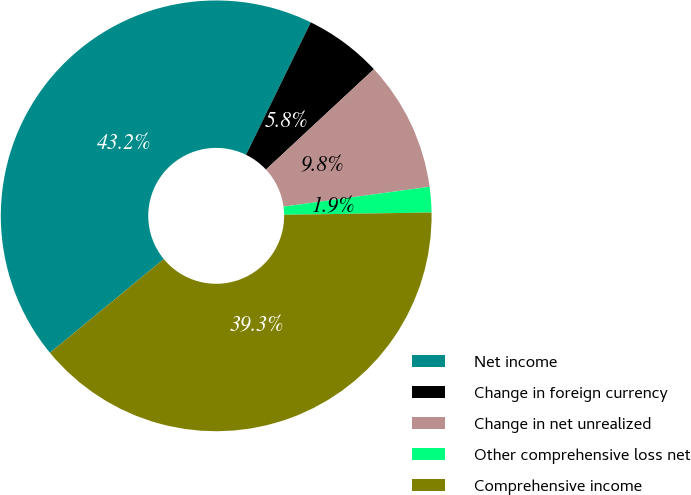<chart> <loc_0><loc_0><loc_500><loc_500><pie_chart><fcel>Net income<fcel>Change in foreign currency<fcel>Change in net unrealized<fcel>Other comprehensive loss net<fcel>Comprehensive income<nl><fcel>43.21%<fcel>5.84%<fcel>9.77%<fcel>1.91%<fcel>39.28%<nl></chart> 